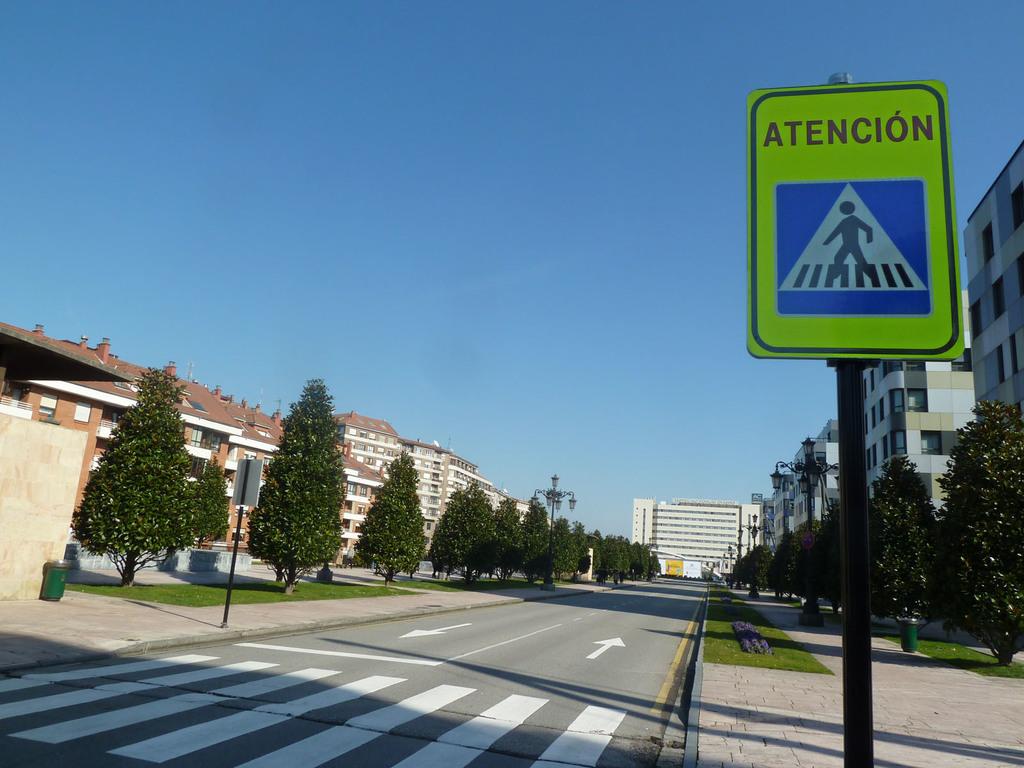What is the sign asking from the driver?
Make the answer very short. Atencion. What language is the sign?
Offer a terse response. Spanish. 